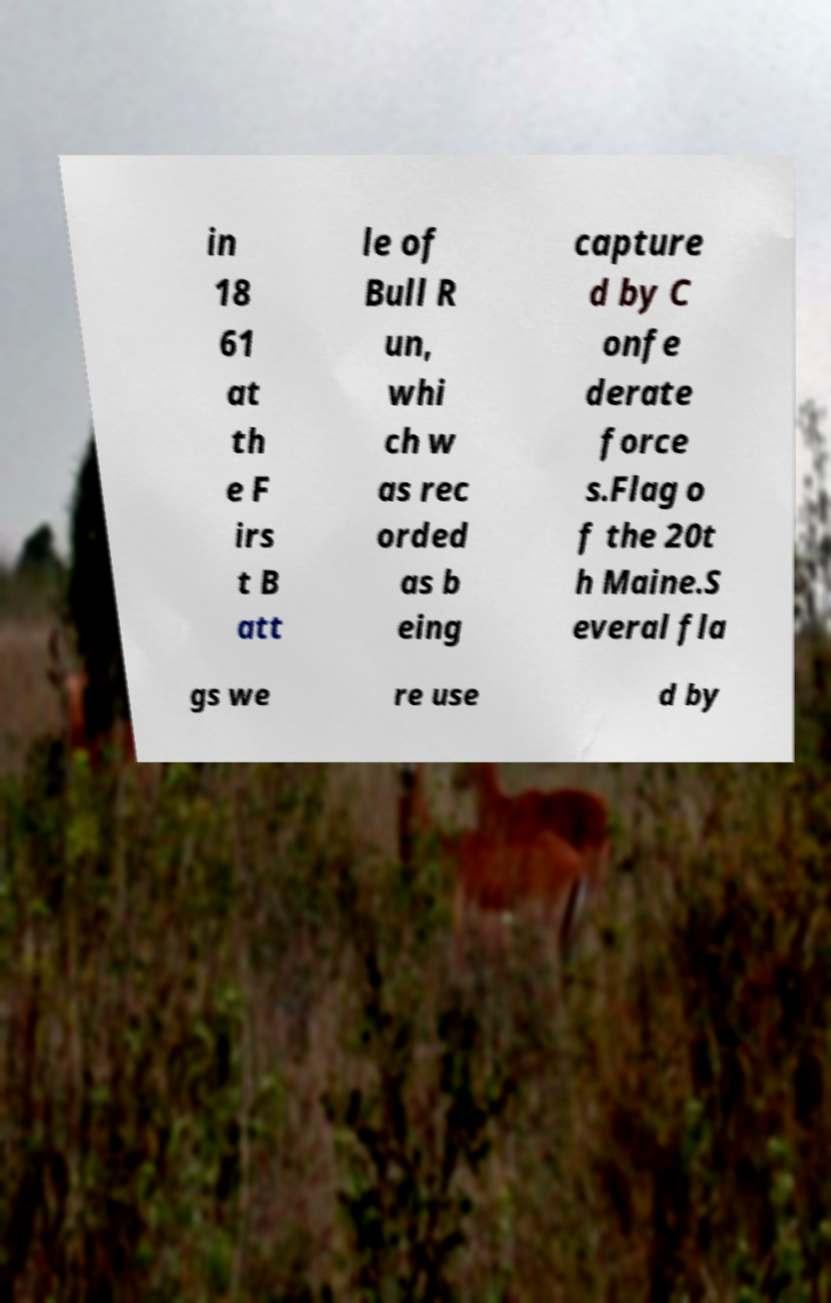Can you read and provide the text displayed in the image?This photo seems to have some interesting text. Can you extract and type it out for me? in 18 61 at th e F irs t B att le of Bull R un, whi ch w as rec orded as b eing capture d by C onfe derate force s.Flag o f the 20t h Maine.S everal fla gs we re use d by 